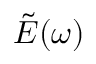Convert formula to latex. <formula><loc_0><loc_0><loc_500><loc_500>\tilde { E } ( \omega )</formula> 